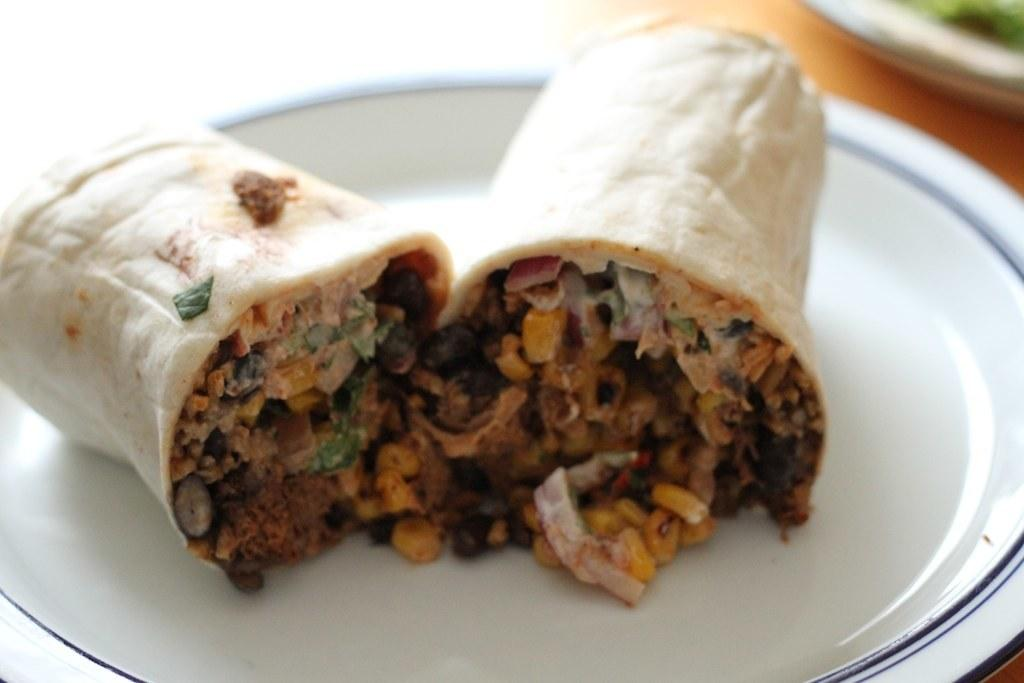What is the main subject of the image? The main subject of the image is food. What can be observed about the plate that holds the food? The plate is white in color. Where is the plate placed in the image? The plate is placed on a brown color table. What type of cord is connected to the food in the image? There is no cord connected to the food in the image. How many flies can be seen hovering around the food in the image? There are no flies present in the image. 